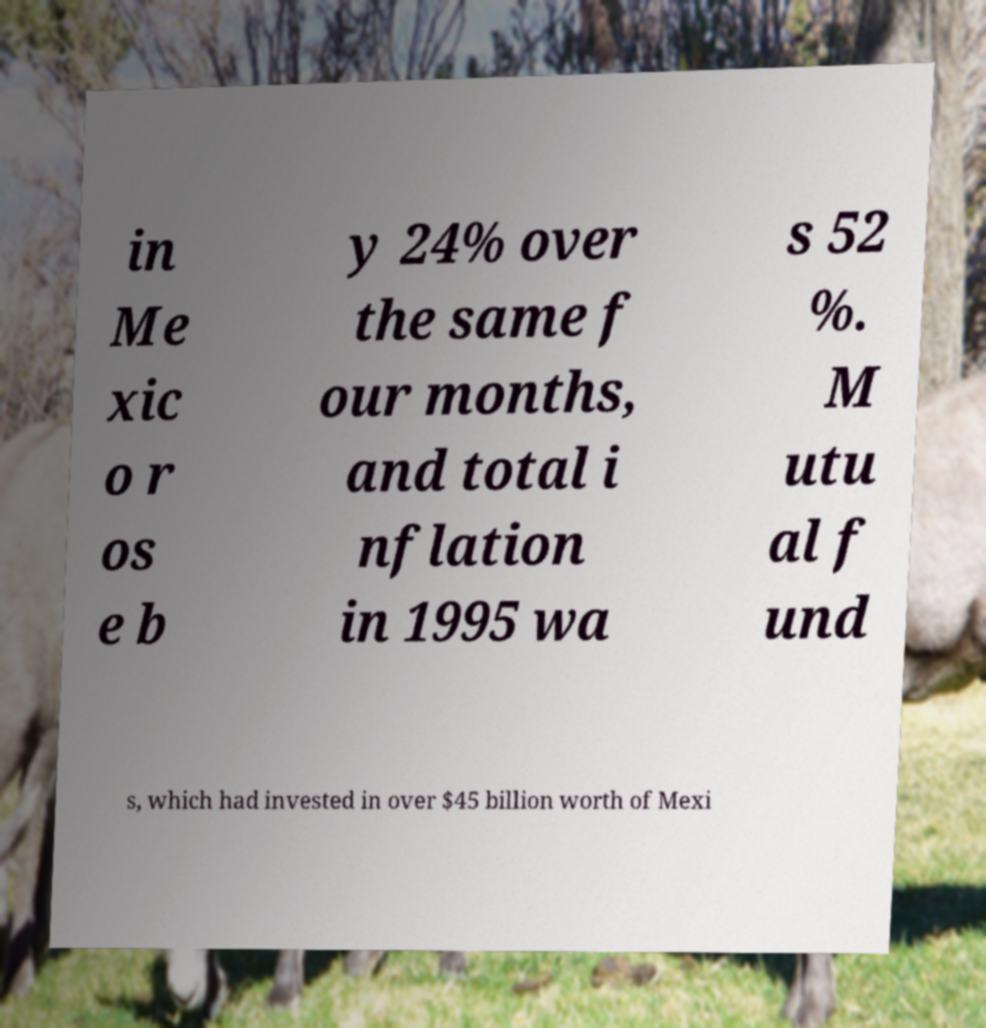Can you accurately transcribe the text from the provided image for me? in Me xic o r os e b y 24% over the same f our months, and total i nflation in 1995 wa s 52 %. M utu al f und s, which had invested in over $45 billion worth of Mexi 